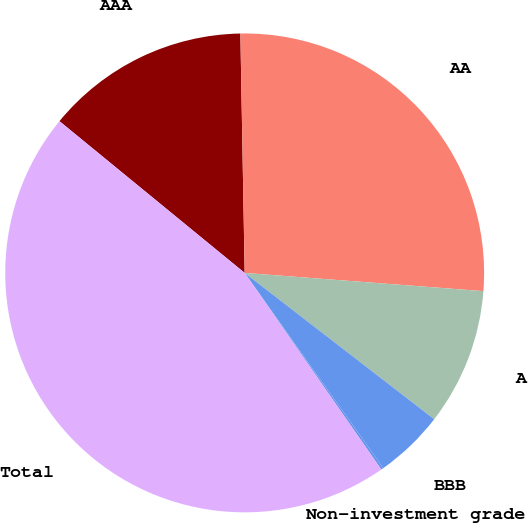Convert chart to OTSL. <chart><loc_0><loc_0><loc_500><loc_500><pie_chart><fcel>AAA<fcel>AA<fcel>A<fcel>BBB<fcel>Non-investment grade<fcel>Total<nl><fcel>13.79%<fcel>26.5%<fcel>9.25%<fcel>4.71%<fcel>0.16%<fcel>45.59%<nl></chart> 